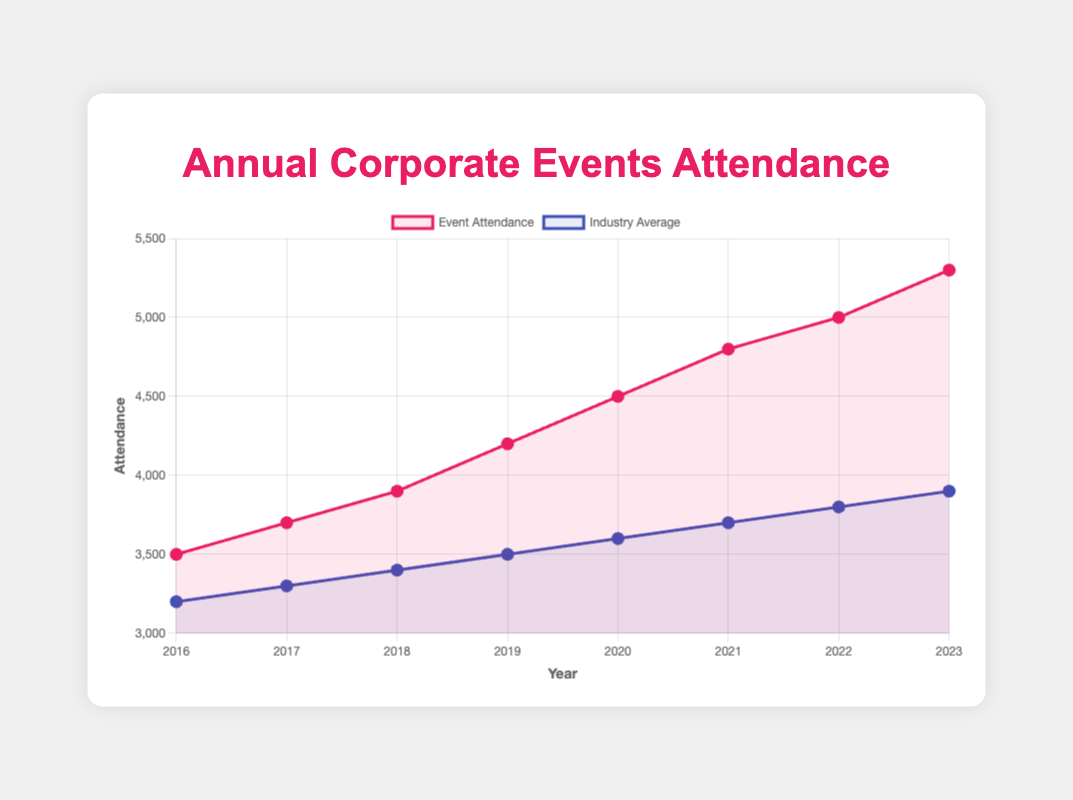How did the annual attendance compare to the industry average in 2023? In 2023, the event attendance was 5300, and the industry average attendance was 3900.
Answer: Annual attendance was higher than the industry average by 1400 What is the trend of event attendance from 2016 to 2023? By observing the line representing event attendance, we see a consistent upward trend from 3500 in 2016 to 5300 in 2023.
Answer: Upward trend Which year had the highest event attendance, and who was the headliner that year? The year with the highest attendance was 2023 with 5300 attendees, and the headliner was P!nk.
Answer: 2023, P!nk How does the event attendance in 2019 compare to the industry average that year? In 2019, the event attendance was 4200, and the industry average attendance was 3500.
Answer: Event attendance was higher by 700 Calculate the average attendance of the event from 2016 to 2023. Sum the attendance values from 2016 to 2023: 3500 + 3700 + 3900 + 4200 + 4500 + 4800 + 5000 + 5300 = 34900. Divide by the number of years (8): 34900/8 = 4362.5
Answer: 4362.5 In which year was the gap between event attendance and industry average smallest? The smallest gap is calculated by finding the difference between event attendance and industry average for each year: 3500-3200 = 300, 3700-3300 = 400, 3900-3400 = 500, 4200-3500 = 700, 4500-3600 = 900, 4800-3700 = 1100, 5000-3800 = 1200, 5300-3900 = 1400. The smallest difference is 300 in 2016.
Answer: 2016 What color represents the industry average line in the chart? The line representing the industry average is blue.
Answer: Blue How much did the attendance increase from 2020 to 2023 for P!nk's performances? Attendance in 2020 was 4500 and in 2023 it was 5300. The increase is 5300 - 4500 = 800.
Answer: 800 Which headliner saw the largest single-year increase in attendance from the previous year? Calculate the difference in attendance each year: 3700-3500 = 200, 3900-3700 = 200, 4200-3900 = 300, 4500-4200 = 300, 4800-4500 = 300, 5000-4800 = 200, 5300-5000 = 300. The largest increase is 300 in 2019 (Ariana Grande), 2020 (P!nk), and 2023 (P!nk).
Answer: Ariana Grande (2019), P!nk (2020), P!nk (2023) What is the percentage increase in attendance from 2016 to 2023? The attendance in 2016 was 3500 and in 2023 it was 5300. The increase is 5300 - 3500 = 1800. The percentage increase is (1800/3500) * 100 = ~51.43%.
Answer: ~51.43% 